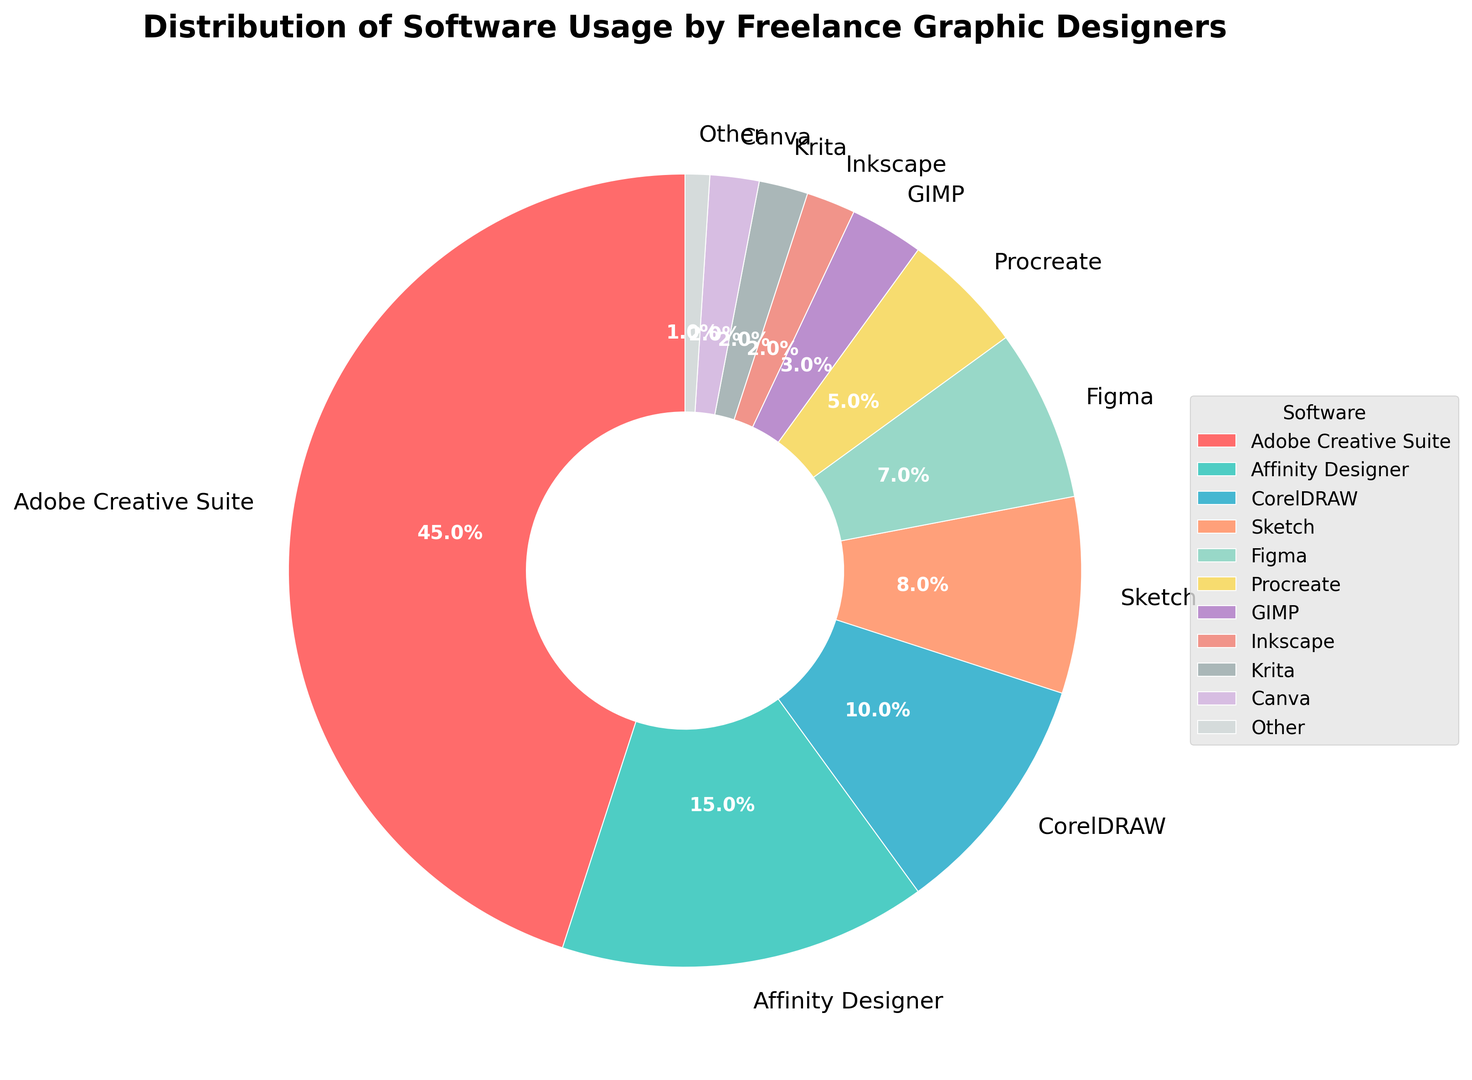Which software has the highest usage percentage? The pie chart clearly shows Adobe Creative Suite having the largest segment. Its segment visually occupies the biggest portion of the chart.
Answer: Adobe Creative Suite Which software has the lowest usage percentage? According to the chart, the smallest segment represents "Other" software. This section is visually the smallest slice of the pie.
Answer: Other What is the combined usage percentage of CorelDRAW and Sketch? CorelDRAW has a usage percentage of 10%, and Sketch has 8%. Adding these percentages together gives 10% + 8% = 18%.
Answer: 18% How does the usage of Figma compare to Procreate? The chart shows Figma has a 7% usage rate, while Procreate has 5%. Since 7% is greater than 5%, Figma is used more than Procreate.
Answer: Figma is used more What is the combined usage percentage of the least popular four software tools? The four least popular tools are Krita (2%), Inkscape (2%), Canva (2%), and Other (1%). Summing these gives 2% + 2% + 2% + 1% = 7%.
Answer: 7% What is the approximate usage percentage of software tools that have less than 10% usage each? The tools under 10% usage are Sketch (8%), Figma (7%), Procreate (5%), GIMP (3%), Inkscape (2%), Krita (2%), Canva (2%), and Other (1%). Summing these values results in 8% + 7% + 5% + 3% + 2% + 2% + 2% +1% = 30%.
Answer: 30% How does the usage of Affinity Designer compare to CorelDRAW? The chart shows Affinity Designer with 15% usage and CorelDRAW with 10%. Since 15% is greater than 10%, Affinity Designer has higher usage.
Answer: Affinity Designer has higher usage What is the difference in the usage percentage between the most and least used software? The most used software is Adobe Creative Suite at 45%, and the least used is Other at 1%. The difference is 45% - 1% = 44%.
Answer: 44% How many software tools have a usage percentage between 2% and 10%? The pie chart indicates that CorelDRAW (10%), Sketch (8%), Figma (7%), and Procreate (5%) fill this range. This gives us four software tools.
Answer: 4 Which software appears in the color green on the chart? According to the custom colors defined, Affinity Designer is represented by green. The slice corresponding to Affinity Designer is visibly green.
Answer: Affinity Designer 